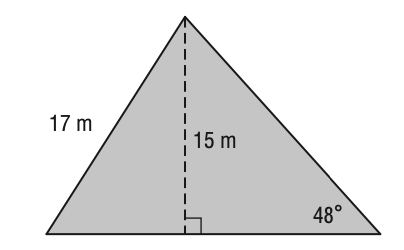Question: What is the area of the triangle? Round your answer to the nearest tenth if necessary.
Choices:
A. 137.4
B. 161.3
C. 170.5
D. 186.9
Answer with the letter. Answer: B 